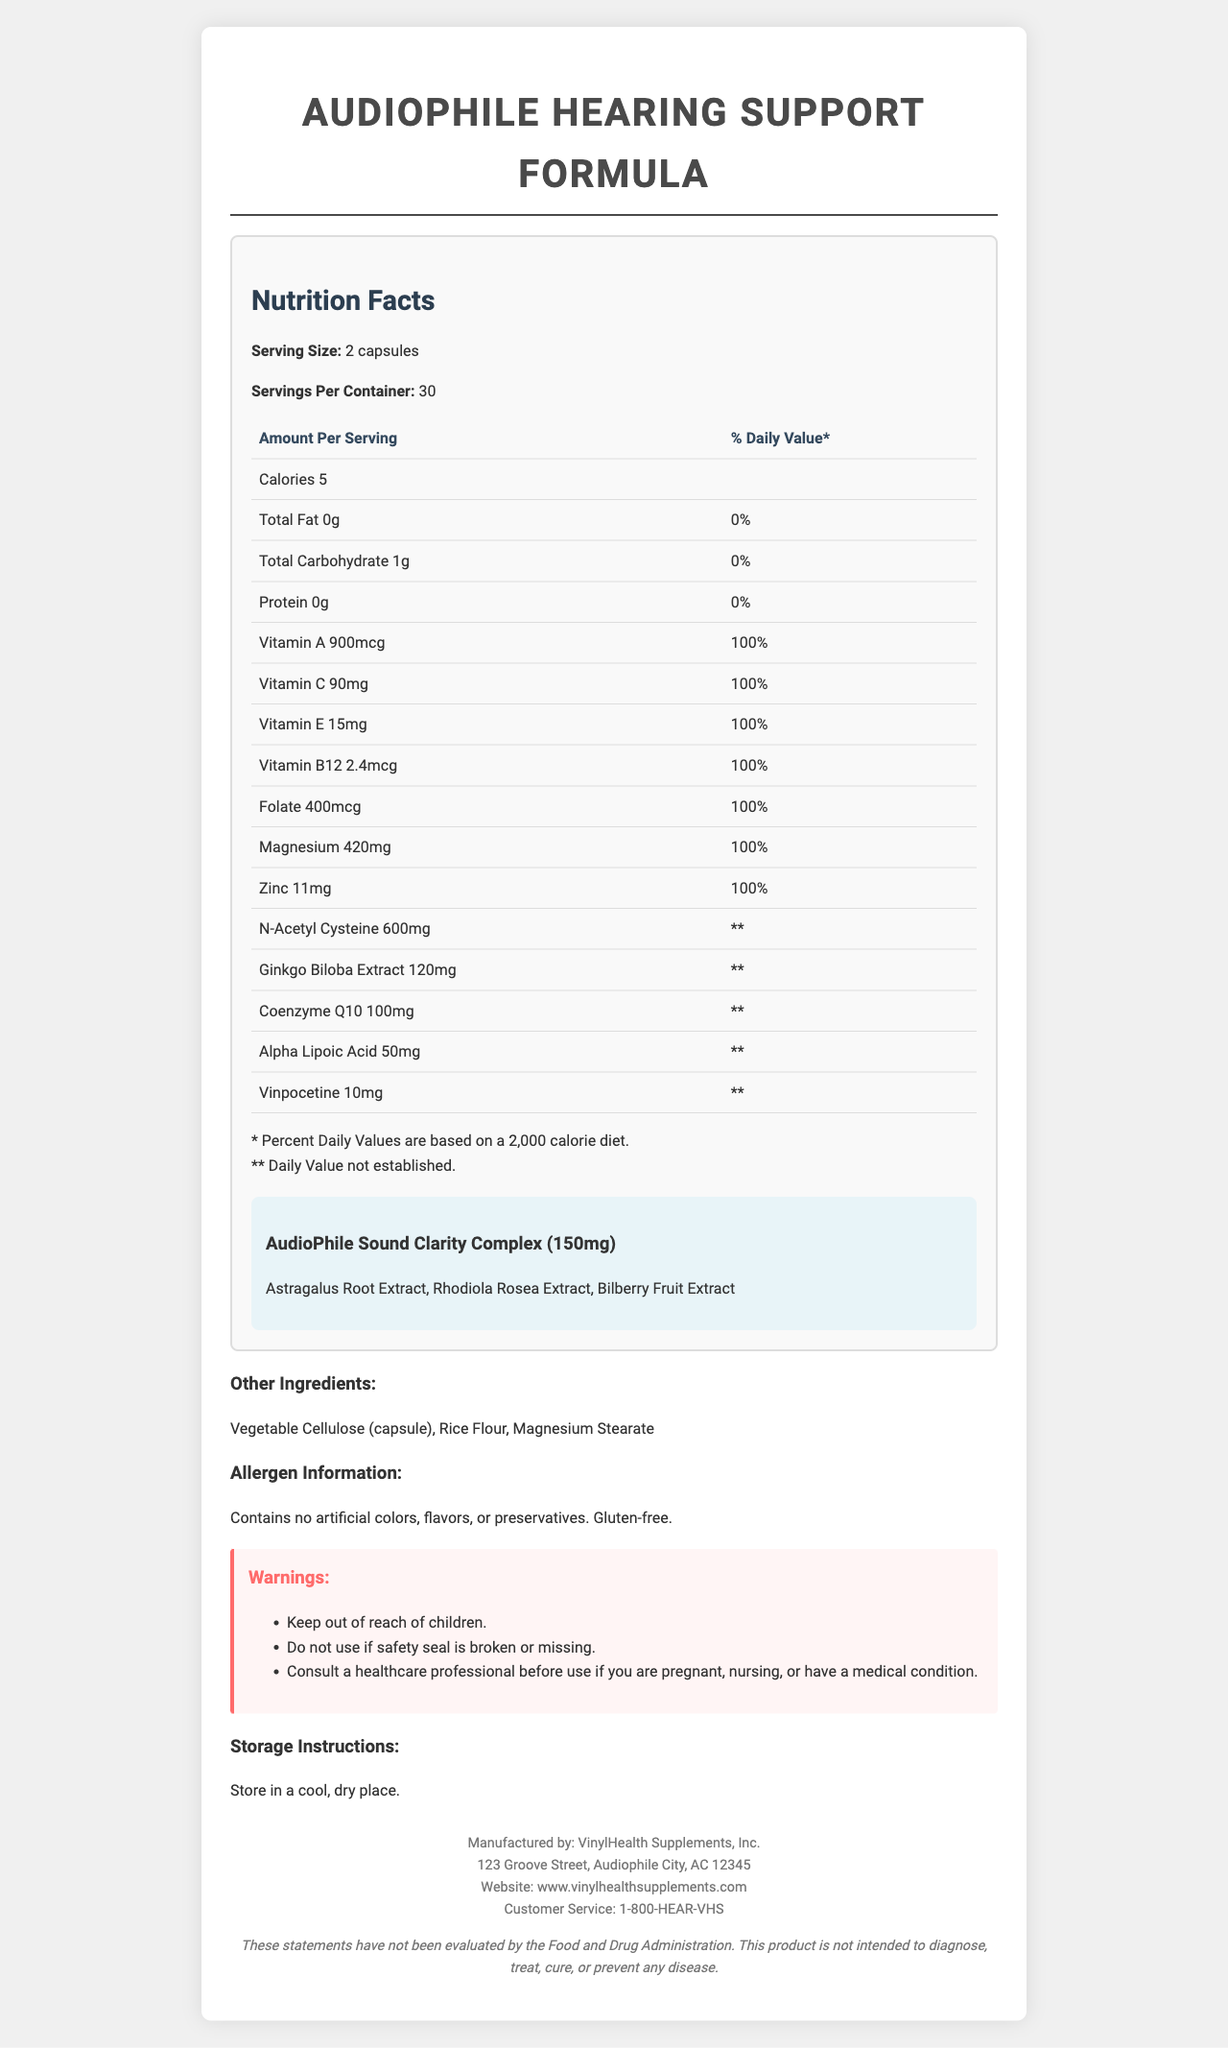what is the serving size? The serving size is displayed in the Nutrition Facts section as "Serving Size: 2 capsules".
Answer: 2 capsules how many servings are there per container? The Nutrition Facts section specifies "Servings Per Container: 30".
Answer: 30 how many calories are in each serving? The Nutrition Facts section lists "Calories: 5".
Answer: 5 how much folate is in each serving? Folate is listed as "Folate: 400mcg" in the table under the Nutrition Facts section.
Answer: 400mcg what are the three ingredients in the proprietary blend? The proprietary blend named "AudioPhile Sound Clarity Complex" contains these three ingredients, as listed in the Nutrition Facts section.
Answer: Astragalus Root Extract, Rhodiola Rosea Extract, Bilberry Fruit Extract which ingredient has the highest amount per serving? A. Ginkgo Biloba Extract B. N-Acetyl Cysteine C. Coenzyme Q10 D. Magnesium N-Acetyl Cysteine is listed as 600mg, which is the highest amount among the options.
Answer: B which vitamins are present in this supplement? I. Vitamin A II. Vitamin C III. Vitamin D IV. Vitamin E V. Vitamin B12 The listed vitamins in the Nutrition Facts section are Vitamin A, Vitamin C, Vitamin E, and Vitamin B12. Vitamin D is not mentioned.
Answer: I, II, IV, V can this supplement be taken by someone with a gluten allergy? The allergen information indicates that the product is gluten-free.
Answer: Yes should the supplement be stored in a refrigerator? The storage instructions mention storing in a "cool, dry place" which does not necessarily imply refrigeration.
Answer: No is there a recommendation to consult a healthcare professional before use? The warnings section includes a note to consult a healthcare professional if pregnant, nursing, or having a medical condition.
Answer: Yes which vitamin contributes 100% of the daily value per serving for adults? Under the Nutrition Facts, Vitamin C is listed with a % Daily Value of 100%.
Answer: Vitamin C describe the main purpose and composition of the AudioPhile Hearing Support Formula. This summary combines details of the supplement’s purpose, key ingredients, allergen information, warnings, and storage instructions.
Answer: The AudioPhile Hearing Support Formula is a vitamin supplement designed to support hearing health, particularly tailored for audiophiles. Each serving (2 capsules) contains a variety of vitamins (A, C, E, B12, Folate), minerals (Magnesium, Zinc), and other compounds such as N-Acetyl Cysteine, Ginkgo Biloba Extract, Coenzyme Q10, Alpha Lipoic Acid, and Vinpocetine. It also includes a proprietary blend called "AudioPhile Sound Clarity Complex" with Astragalus Root Extract, Rhodiola Rosea Extract, and Bilberry Fruit Extract. The supplement is gluten-free and contains no artificial colors, flavors, or preservatives. Warnings advise consulting a healthcare professional if pregnant, nursing, or having a medical condition, and to store the product in a cool, dry place. is this product evaluated by the Food and Drug Administration? The disclaimer at the bottom states that the statements have not been evaluated by the FDA.
Answer: No what is the recommended dosage for tinnitus patients? The document does not provide specific usage recommendations for tinnitus or any other specific condition.
Answer: Not enough information 